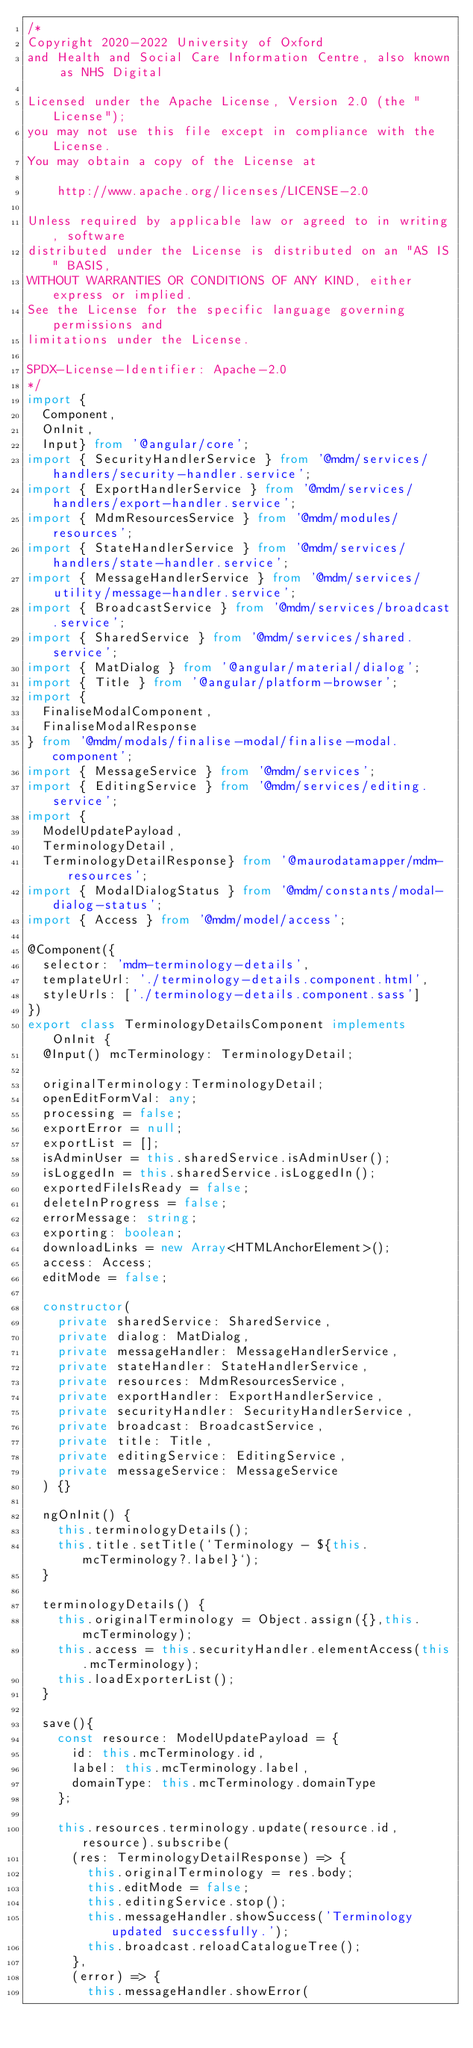<code> <loc_0><loc_0><loc_500><loc_500><_TypeScript_>/*
Copyright 2020-2022 University of Oxford
and Health and Social Care Information Centre, also known as NHS Digital

Licensed under the Apache License, Version 2.0 (the "License");
you may not use this file except in compliance with the License.
You may obtain a copy of the License at

    http://www.apache.org/licenses/LICENSE-2.0

Unless required by applicable law or agreed to in writing, software
distributed under the License is distributed on an "AS IS" BASIS,
WITHOUT WARRANTIES OR CONDITIONS OF ANY KIND, either express or implied.
See the License for the specific language governing permissions and
limitations under the License.

SPDX-License-Identifier: Apache-2.0
*/
import {
  Component,
  OnInit,
  Input} from '@angular/core';
import { SecurityHandlerService } from '@mdm/services/handlers/security-handler.service';
import { ExportHandlerService } from '@mdm/services/handlers/export-handler.service';
import { MdmResourcesService } from '@mdm/modules/resources';
import { StateHandlerService } from '@mdm/services/handlers/state-handler.service';
import { MessageHandlerService } from '@mdm/services/utility/message-handler.service';
import { BroadcastService } from '@mdm/services/broadcast.service';
import { SharedService } from '@mdm/services/shared.service';
import { MatDialog } from '@angular/material/dialog';
import { Title } from '@angular/platform-browser';
import {
  FinaliseModalComponent,
  FinaliseModalResponse
} from '@mdm/modals/finalise-modal/finalise-modal.component';
import { MessageService } from '@mdm/services';
import { EditingService } from '@mdm/services/editing.service';
import {
  ModelUpdatePayload,
  TerminologyDetail,
  TerminologyDetailResponse} from '@maurodatamapper/mdm-resources';
import { ModalDialogStatus } from '@mdm/constants/modal-dialog-status';
import { Access } from '@mdm/model/access';

@Component({
  selector: 'mdm-terminology-details',
  templateUrl: './terminology-details.component.html',
  styleUrls: ['./terminology-details.component.sass']
})
export class TerminologyDetailsComponent implements OnInit {
  @Input() mcTerminology: TerminologyDetail;

  originalTerminology:TerminologyDetail;
  openEditFormVal: any;
  processing = false;
  exportError = null;
  exportList = [];
  isAdminUser = this.sharedService.isAdminUser();
  isLoggedIn = this.sharedService.isLoggedIn();
  exportedFileIsReady = false;
  deleteInProgress = false;
  errorMessage: string;
  exporting: boolean;
  downloadLinks = new Array<HTMLAnchorElement>();
  access: Access;
  editMode = false;

  constructor(
    private sharedService: SharedService,
    private dialog: MatDialog,
    private messageHandler: MessageHandlerService,
    private stateHandler: StateHandlerService,
    private resources: MdmResourcesService,
    private exportHandler: ExportHandlerService,
    private securityHandler: SecurityHandlerService,
    private broadcast: BroadcastService,
    private title: Title,
    private editingService: EditingService,
    private messageService: MessageService
  ) {}

  ngOnInit() {
    this.terminologyDetails();
    this.title.setTitle(`Terminology - ${this.mcTerminology?.label}`);
  }

  terminologyDetails() {
    this.originalTerminology = Object.assign({},this.mcTerminology);
    this.access = this.securityHandler.elementAccess(this.mcTerminology);
    this.loadExporterList();
  }

  save(){
    const resource: ModelUpdatePayload = {
      id: this.mcTerminology.id,
      label: this.mcTerminology.label,
      domainType: this.mcTerminology.domainType
    };

    this.resources.terminology.update(resource.id, resource).subscribe(
      (res: TerminologyDetailResponse) => {
        this.originalTerminology = res.body;
        this.editMode = false;
        this.editingService.stop();
        this.messageHandler.showSuccess('Terminology updated successfully.');
        this.broadcast.reloadCatalogueTree();
      },
      (error) => {
        this.messageHandler.showError(</code> 